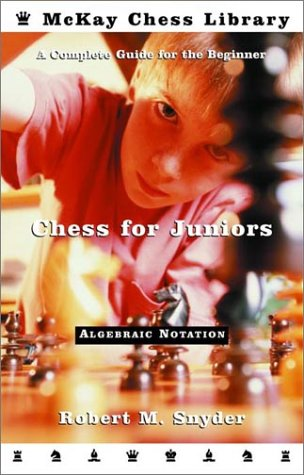Who wrote this book?
Answer the question using a single word or phrase. Robert M. Snyder What is the title of this book? Chess for Juniors: A Complete Guide for the Beginner What type of book is this? Humor & Entertainment Is this a comedy book? Yes Is this a comics book? No 